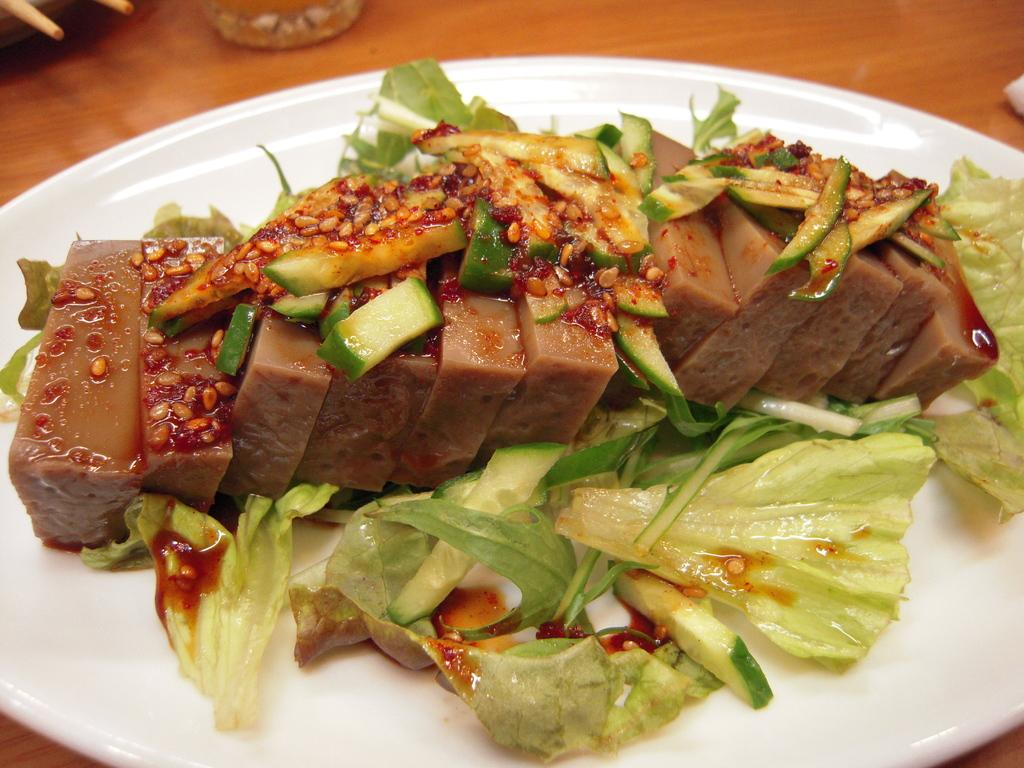What piece of furniture is present in the image? There is a table in the image. What is placed on the table? There is a white plate on the table. What type of food is on the plate? The plate contains cabbage slices, which are vegetables. Is there any additional element on the vegetables? Yes, there is a sauce on the vegetables. What type of cannon is used to cook the vegetables in the image? There is no cannon present in the image, and cannons are not used for cooking vegetables. 